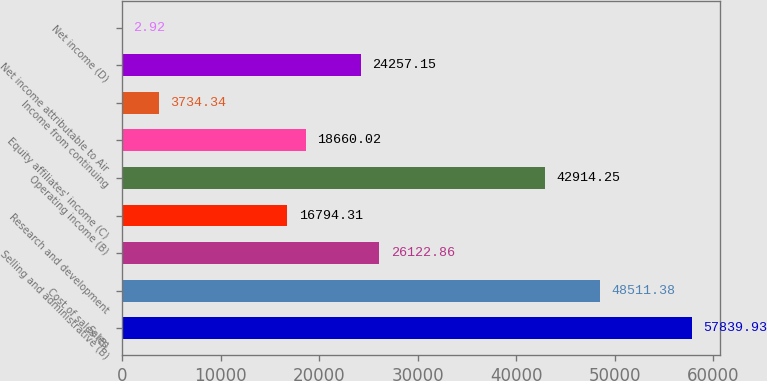Convert chart to OTSL. <chart><loc_0><loc_0><loc_500><loc_500><bar_chart><fcel>Sales<fcel>Cost of sales (B)<fcel>Selling and administrative (B)<fcel>Research and development<fcel>Operating income (B)<fcel>Equity affiliates' income (C)<fcel>Income from continuing<fcel>Net income attributable to Air<fcel>Net income (D)<nl><fcel>57839.9<fcel>48511.4<fcel>26122.9<fcel>16794.3<fcel>42914.2<fcel>18660<fcel>3734.34<fcel>24257.2<fcel>2.92<nl></chart> 